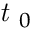<formula> <loc_0><loc_0><loc_500><loc_500>t _ { 0 }</formula> 